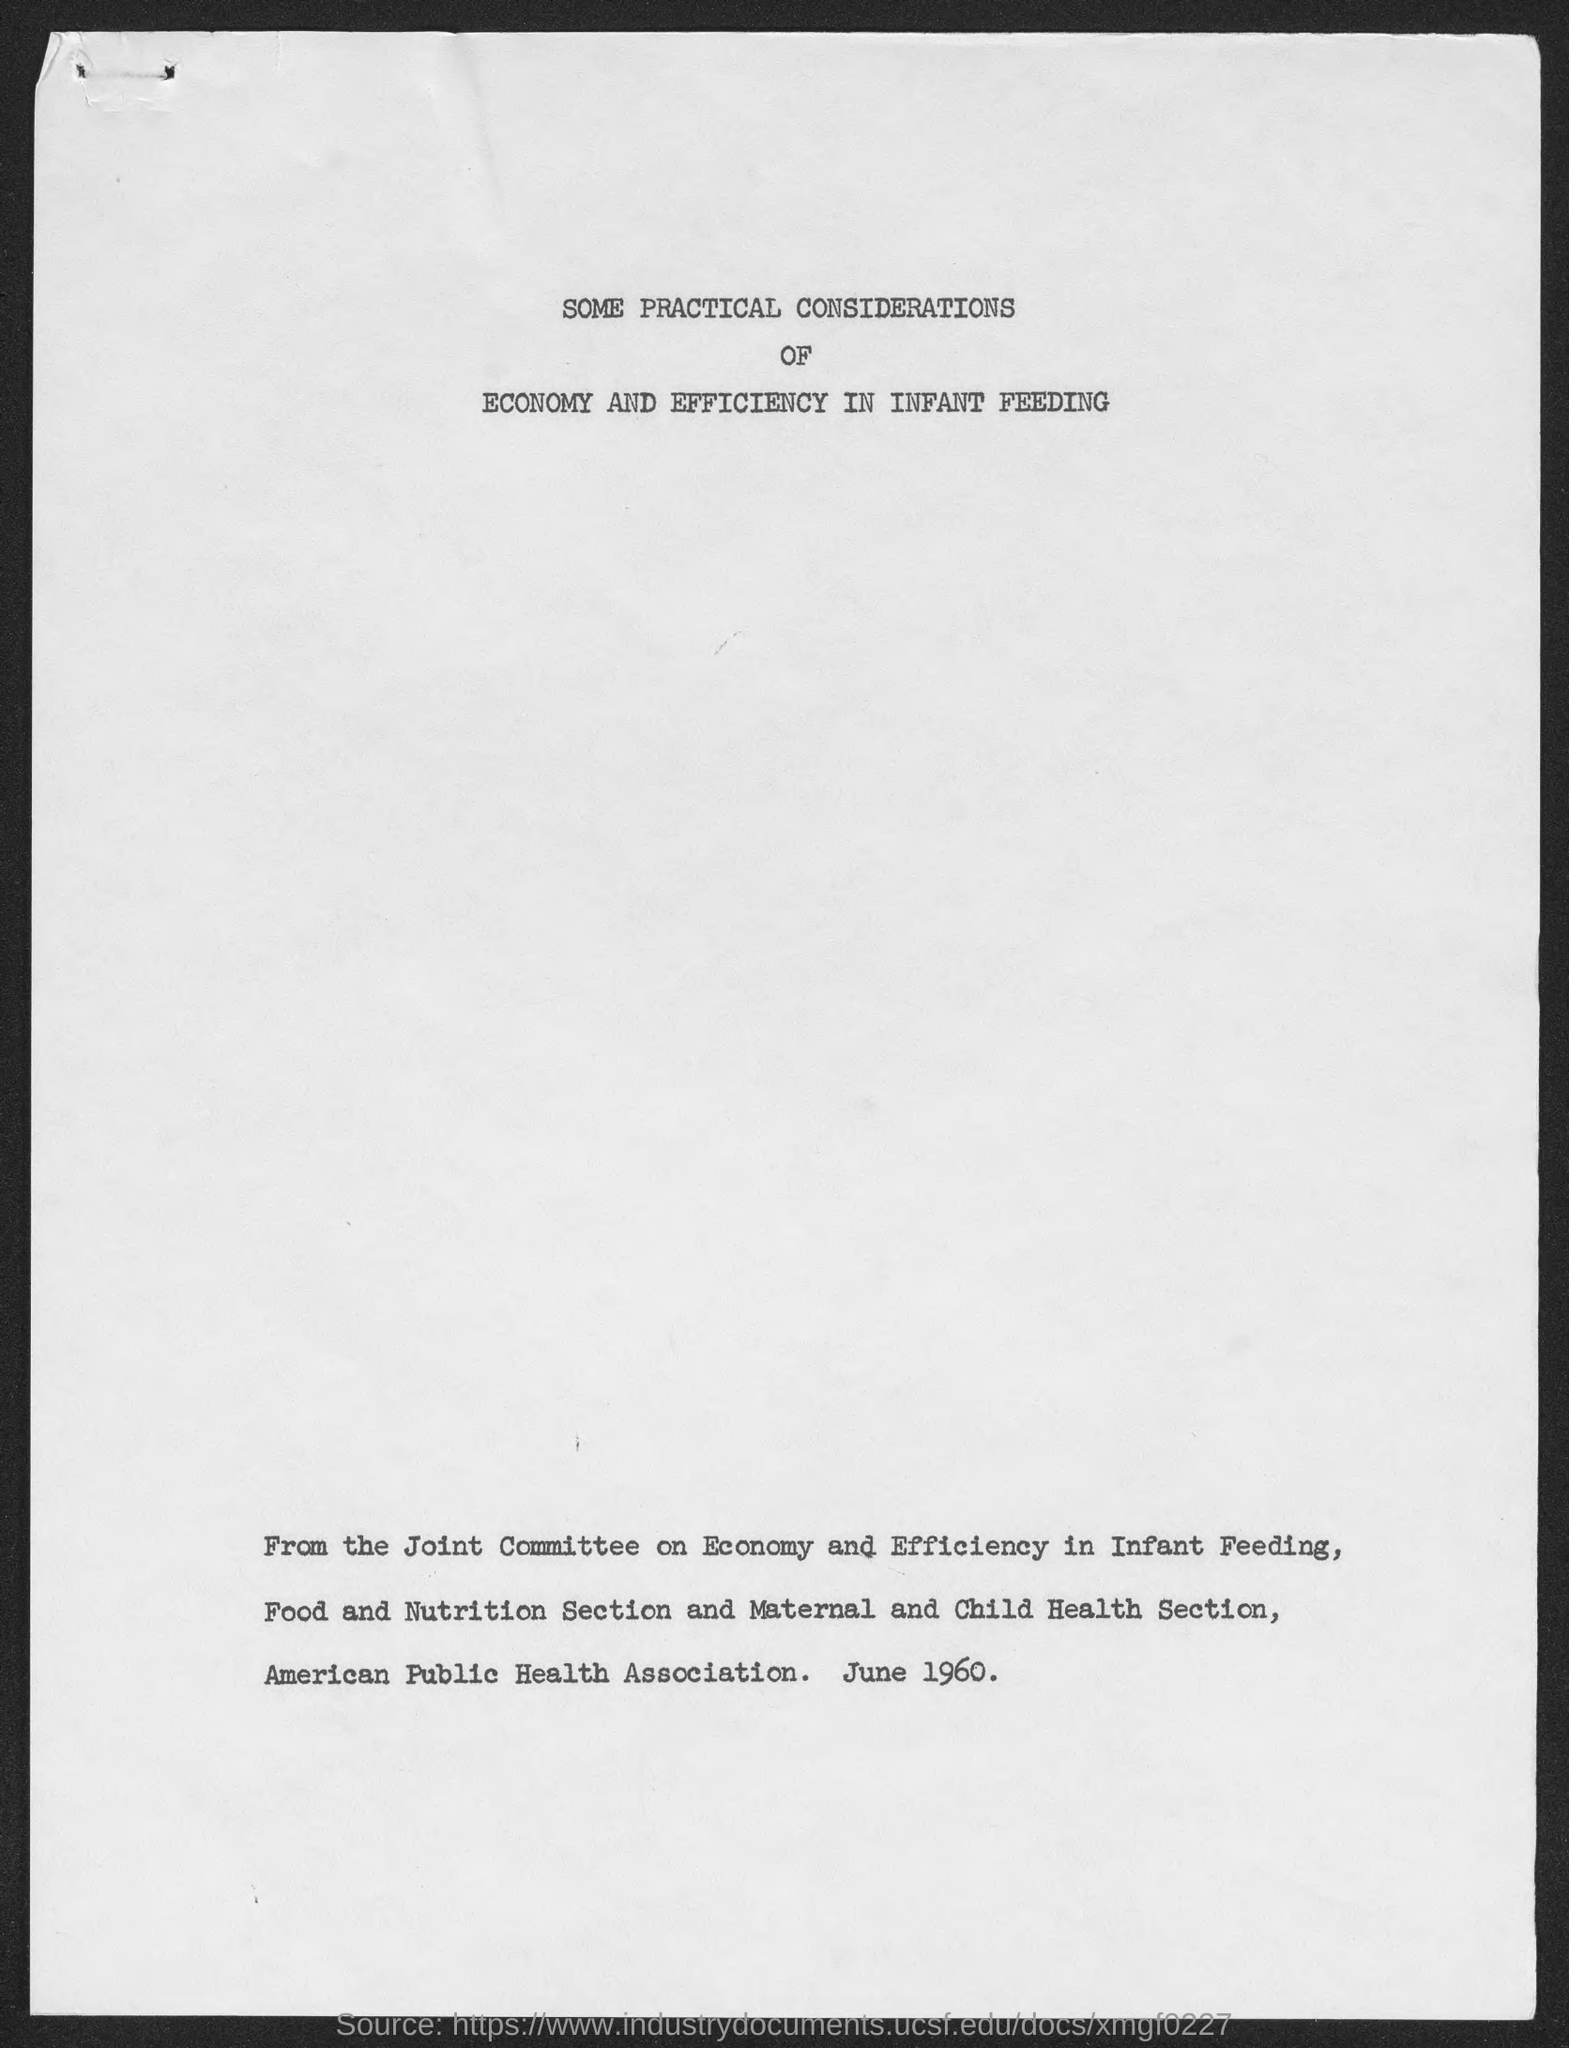What is the date beside american public health association?
Ensure brevity in your answer.  June 1960. 